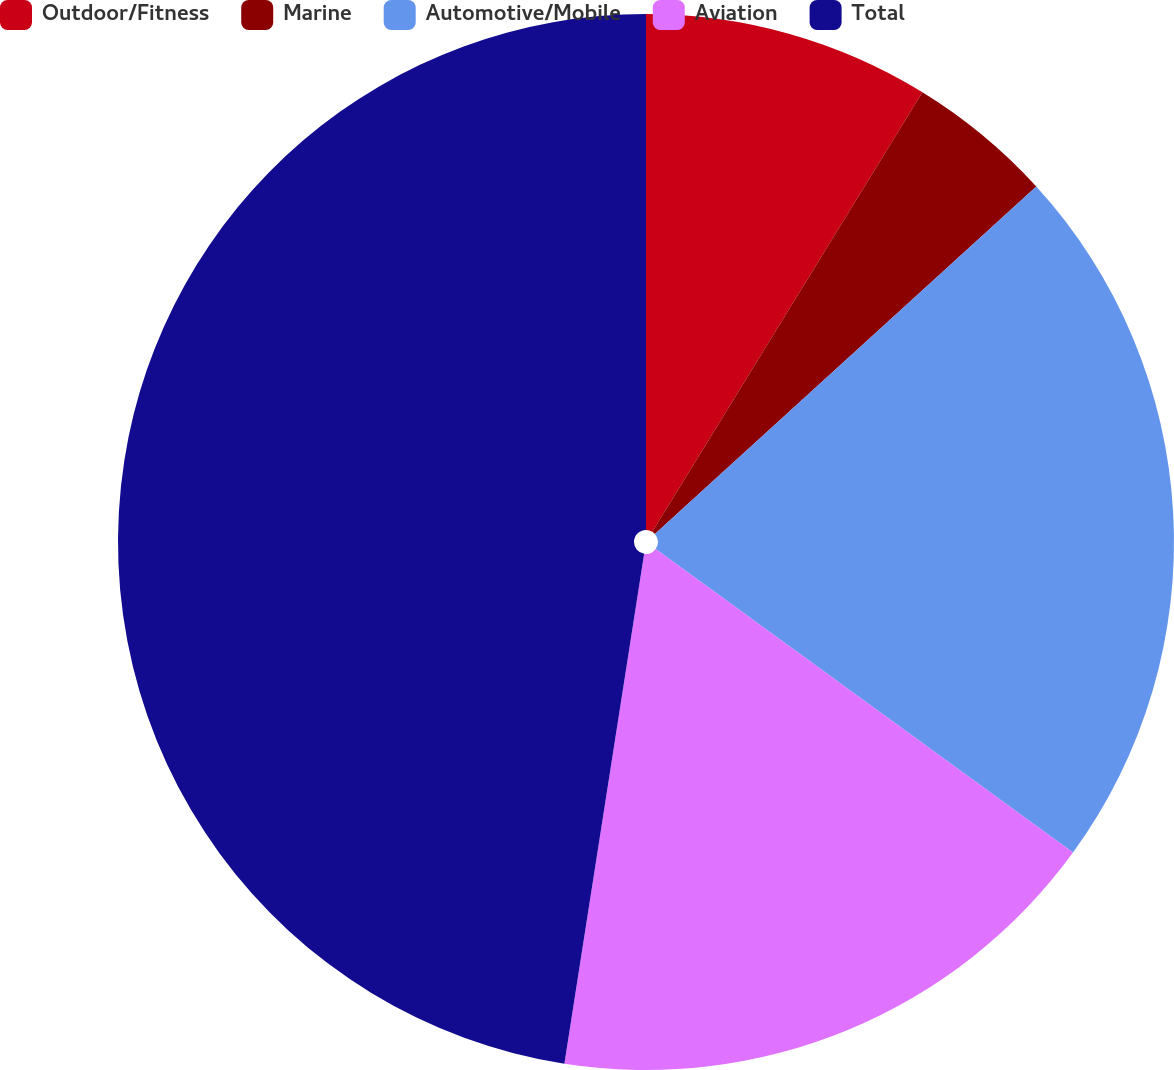Convert chart to OTSL. <chart><loc_0><loc_0><loc_500><loc_500><pie_chart><fcel>Outdoor/Fitness<fcel>Marine<fcel>Automotive/Mobile<fcel>Aviation<fcel>Total<nl><fcel>8.77%<fcel>4.47%<fcel>21.77%<fcel>17.46%<fcel>47.53%<nl></chart> 